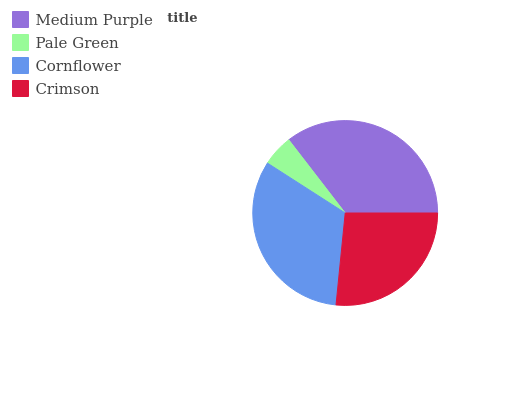Is Pale Green the minimum?
Answer yes or no. Yes. Is Medium Purple the maximum?
Answer yes or no. Yes. Is Cornflower the minimum?
Answer yes or no. No. Is Cornflower the maximum?
Answer yes or no. No. Is Cornflower greater than Pale Green?
Answer yes or no. Yes. Is Pale Green less than Cornflower?
Answer yes or no. Yes. Is Pale Green greater than Cornflower?
Answer yes or no. No. Is Cornflower less than Pale Green?
Answer yes or no. No. Is Cornflower the high median?
Answer yes or no. Yes. Is Crimson the low median?
Answer yes or no. Yes. Is Crimson the high median?
Answer yes or no. No. Is Medium Purple the low median?
Answer yes or no. No. 